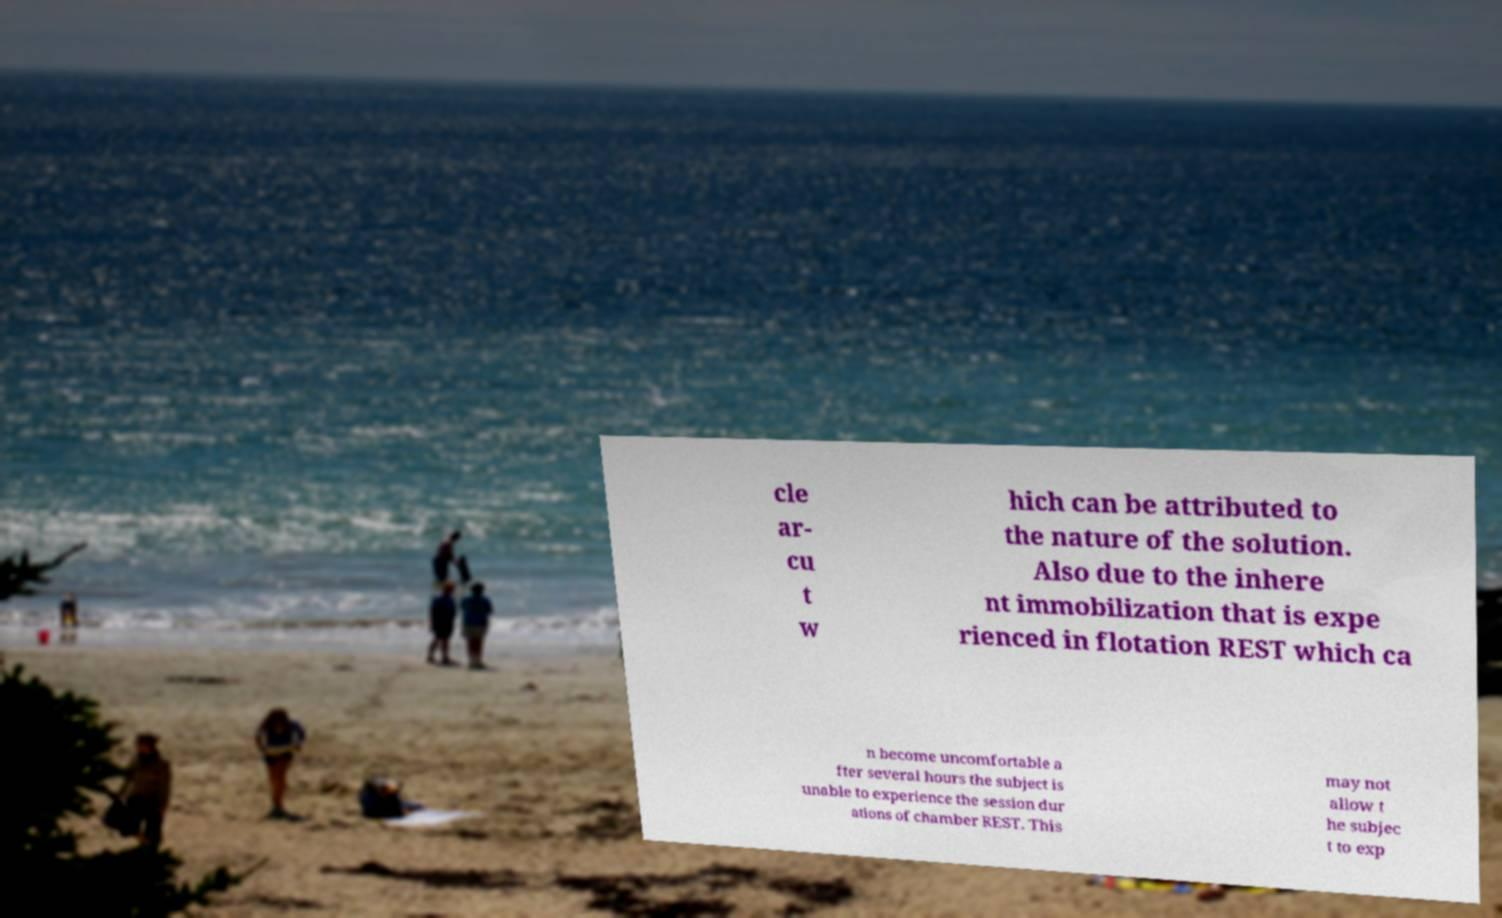What messages or text are displayed in this image? I need them in a readable, typed format. cle ar- cu t w hich can be attributed to the nature of the solution. Also due to the inhere nt immobilization that is expe rienced in flotation REST which ca n become uncomfortable a fter several hours the subject is unable to experience the session dur ations of chamber REST. This may not allow t he subjec t to exp 